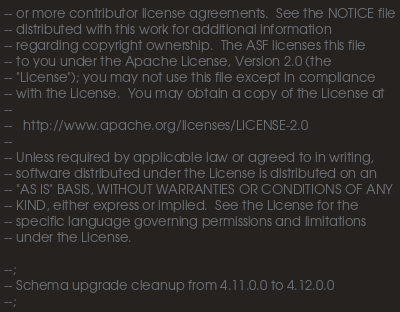Convert code to text. <code><loc_0><loc_0><loc_500><loc_500><_SQL_>-- or more contributor license agreements.  See the NOTICE file
-- distributed with this work for additional information
-- regarding copyright ownership.  The ASF licenses this file
-- to you under the Apache License, Version 2.0 (the
-- "License"); you may not use this file except in compliance
-- with the License.  You may obtain a copy of the License at
--
--   http://www.apache.org/licenses/LICENSE-2.0
--
-- Unless required by applicable law or agreed to in writing,
-- software distributed under the License is distributed on an
-- "AS IS" BASIS, WITHOUT WARRANTIES OR CONDITIONS OF ANY
-- KIND, either express or implied.  See the License for the
-- specific language governing permissions and limitations
-- under the License.

--;
-- Schema upgrade cleanup from 4.11.0.0 to 4.12.0.0
--;</code> 